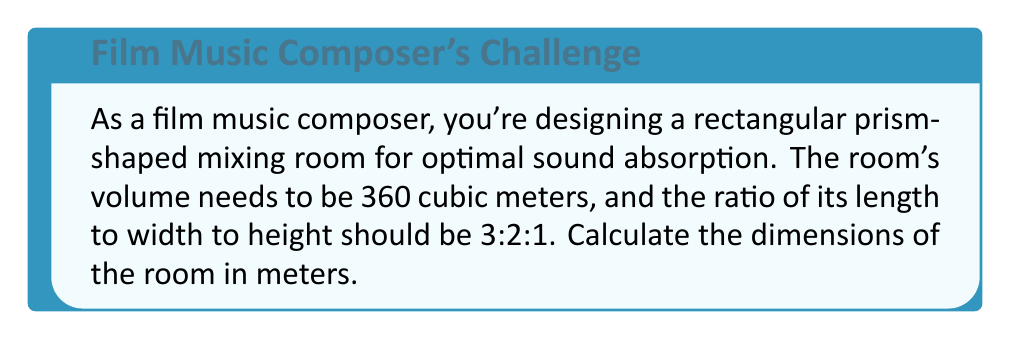Can you answer this question? Let's approach this step-by-step:

1) Let's denote the room's dimensions as follows:
   Length: $3x$
   Width: $2x$
   Height: $x$
   Where $x$ is some unknown value we need to determine.

2) We know the volume of the room is 360 cubic meters. The volume of a rectangular prism is given by length × width × height. So we can set up the equation:

   $$(3x)(2x)(x) = 360$$

3) Simplify the left side of the equation:

   $$6x^3 = 360$$

4) Divide both sides by 6:

   $$x^3 = 60$$

5) Take the cube root of both sides:

   $$x = \sqrt[3]{60} \approx 3.91$$

6) Now that we know $x$, we can calculate the actual dimensions:

   Length: $3x = 3(3.91) \approx 11.73$ meters
   Width: $2x = 2(3.91) \approx 7.82$ meters
   Height: $x \approx 3.91$ meters

7) Let's verify:
   Volume = $11.73 \times 7.82 \times 3.91 \approx 360$ cubic meters (allowing for rounding errors)
   Ratio of length:width:height = $11.73 : 7.82 : 3.91$, which simplifies to $3 : 2 : 1$

This room design satisfies both the volume requirement and the ratio requirement.
Answer: The dimensions of the mixing room are approximately:
Length: 11.73 meters
Width: 7.82 meters
Height: 3.91 meters 